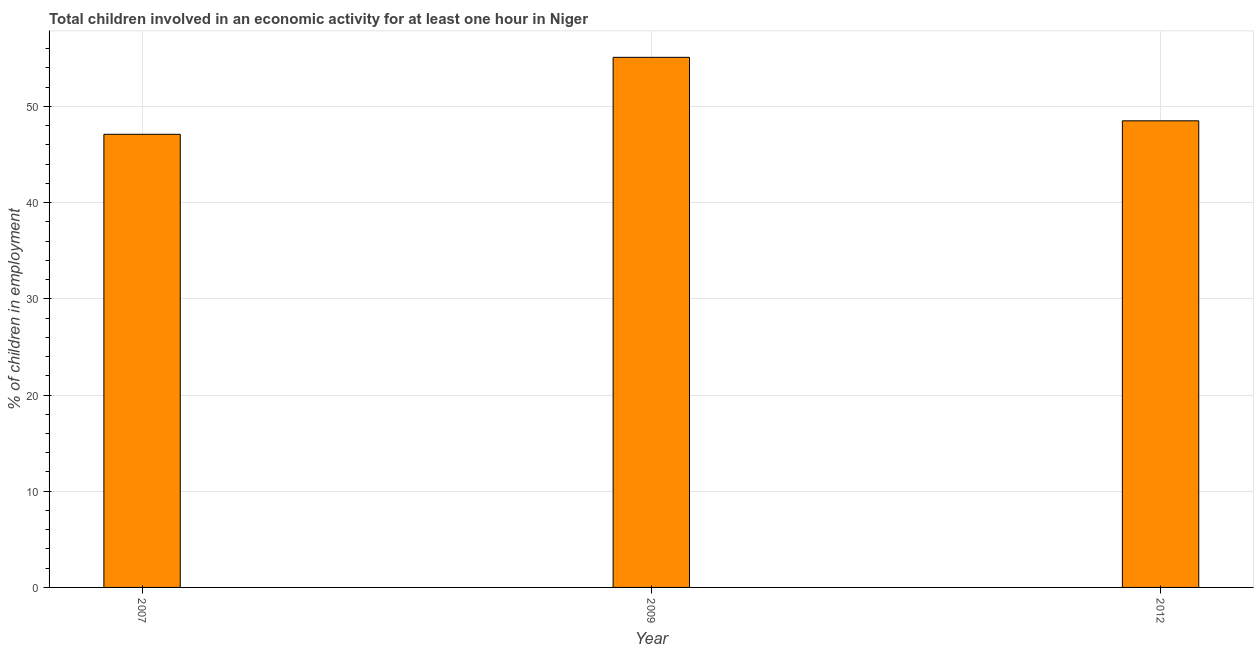Does the graph contain grids?
Your response must be concise. Yes. What is the title of the graph?
Offer a very short reply. Total children involved in an economic activity for at least one hour in Niger. What is the label or title of the Y-axis?
Give a very brief answer. % of children in employment. What is the percentage of children in employment in 2007?
Keep it short and to the point. 47.1. Across all years, what is the maximum percentage of children in employment?
Your answer should be compact. 55.1. Across all years, what is the minimum percentage of children in employment?
Your answer should be very brief. 47.1. In which year was the percentage of children in employment minimum?
Provide a succinct answer. 2007. What is the sum of the percentage of children in employment?
Your response must be concise. 150.7. What is the average percentage of children in employment per year?
Your response must be concise. 50.23. What is the median percentage of children in employment?
Provide a short and direct response. 48.5. In how many years, is the percentage of children in employment greater than 8 %?
Make the answer very short. 3. What is the ratio of the percentage of children in employment in 2007 to that in 2009?
Offer a terse response. 0.85. What is the difference between the highest and the second highest percentage of children in employment?
Make the answer very short. 6.6. In how many years, is the percentage of children in employment greater than the average percentage of children in employment taken over all years?
Provide a short and direct response. 1. What is the difference between two consecutive major ticks on the Y-axis?
Your answer should be compact. 10. What is the % of children in employment in 2007?
Offer a terse response. 47.1. What is the % of children in employment in 2009?
Make the answer very short. 55.1. What is the % of children in employment in 2012?
Your answer should be compact. 48.5. What is the difference between the % of children in employment in 2007 and 2012?
Give a very brief answer. -1.4. What is the ratio of the % of children in employment in 2007 to that in 2009?
Ensure brevity in your answer.  0.85. What is the ratio of the % of children in employment in 2009 to that in 2012?
Make the answer very short. 1.14. 